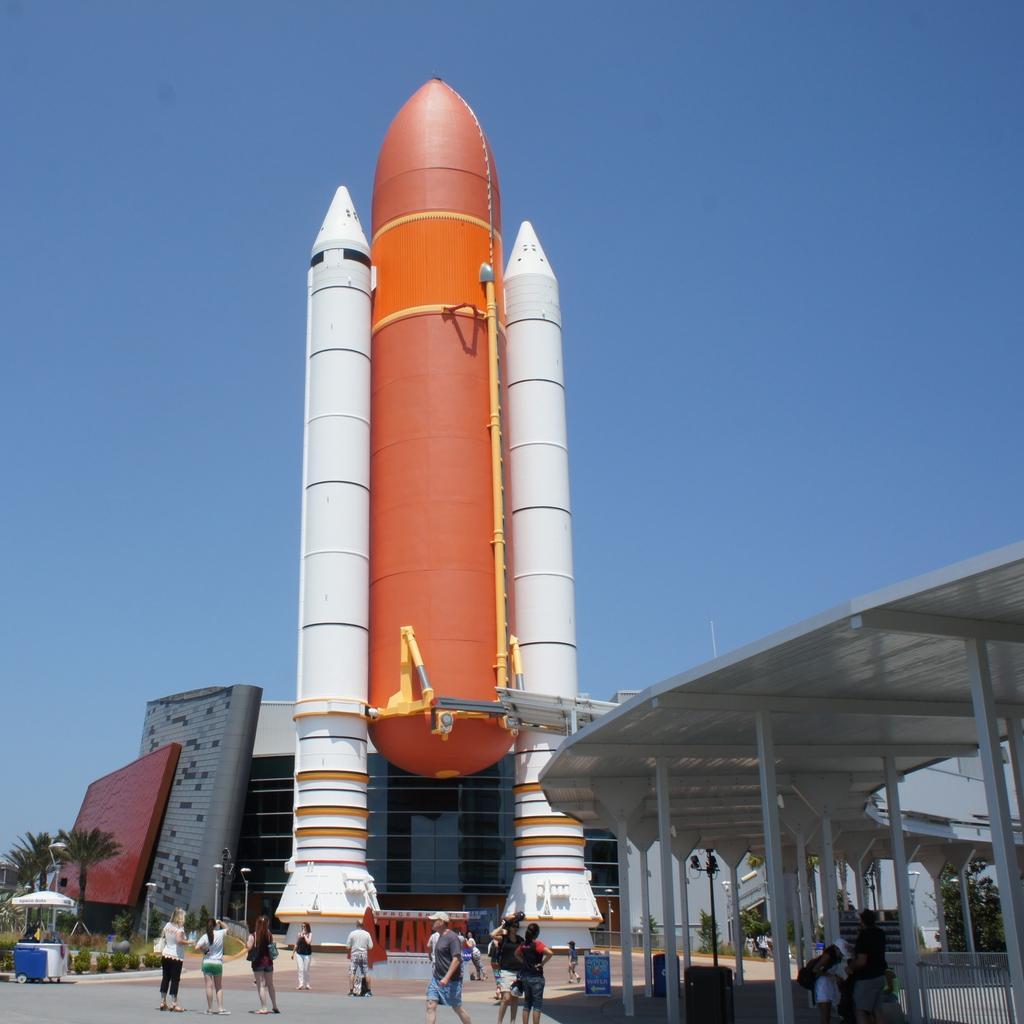Could you give a brief overview of what you see in this image? This picture is clicked outside. In the foreground we can see the group of persons and we can see a gazebo, trees, building, plants and some other objects. In the center we can see a rocket. In the background we can see the sky. 